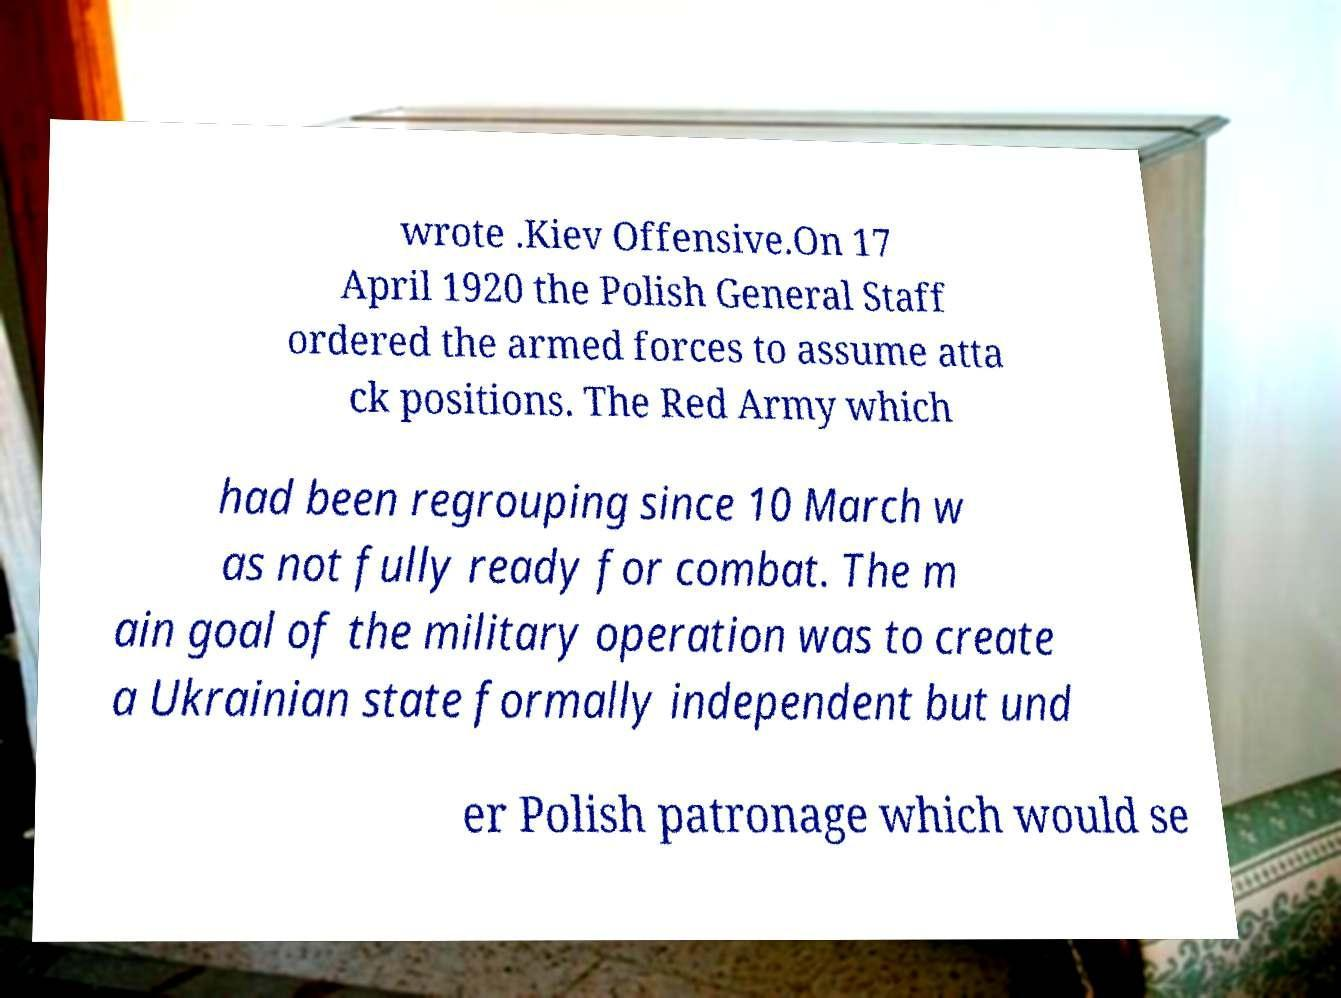Please read and relay the text visible in this image. What does it say? wrote .Kiev Offensive.On 17 April 1920 the Polish General Staff ordered the armed forces to assume atta ck positions. The Red Army which had been regrouping since 10 March w as not fully ready for combat. The m ain goal of the military operation was to create a Ukrainian state formally independent but und er Polish patronage which would se 